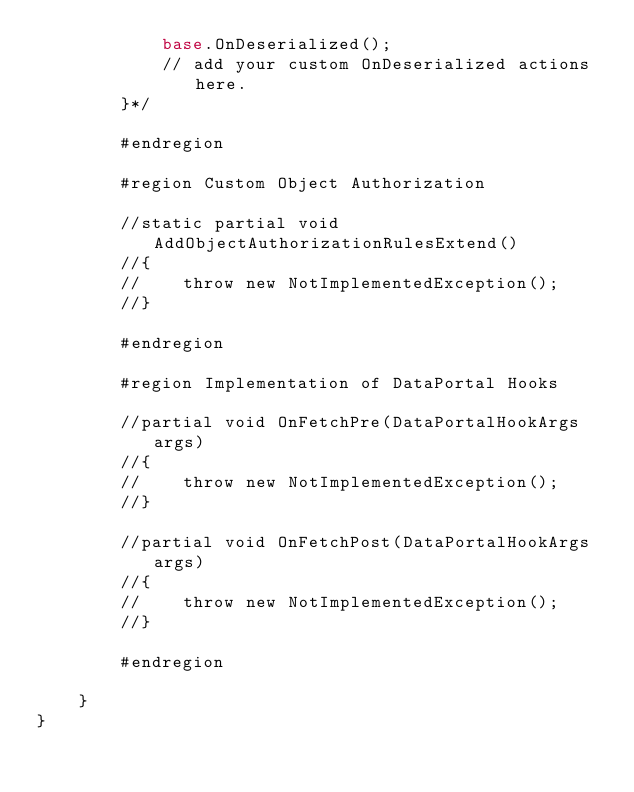Convert code to text. <code><loc_0><loc_0><loc_500><loc_500><_C#_>            base.OnDeserialized();
            // add your custom OnDeserialized actions here.
        }*/

        #endregion

        #region Custom Object Authorization

        //static partial void AddObjectAuthorizationRulesExtend()
        //{
        //    throw new NotImplementedException();
        //}

        #endregion

        #region Implementation of DataPortal Hooks

        //partial void OnFetchPre(DataPortalHookArgs args)
        //{
        //    throw new NotImplementedException();
        //}

        //partial void OnFetchPost(DataPortalHookArgs args)
        //{
        //    throw new NotImplementedException();
        //}

        #endregion

    }
}
</code> 